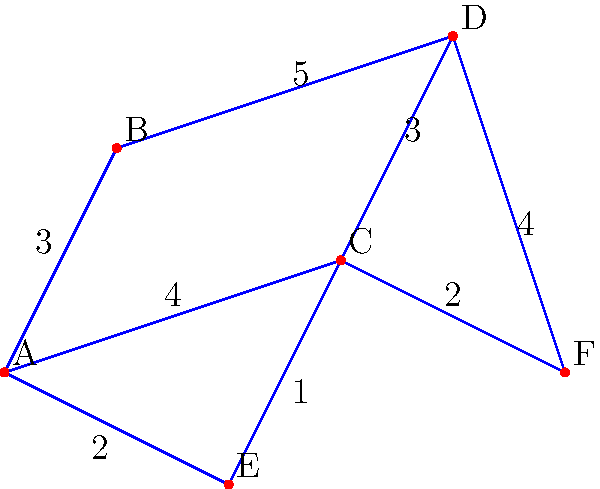As the Student Union leader, you're tasked with designing an efficient network for distributing student information across campus. The graph represents different locations on campus, with edges representing possible connections and their associated costs. What is the total cost of the minimal spanning tree that ensures all locations are connected while minimizing the overall expense? To find the minimal spanning tree, we'll use Kruskal's algorithm:

1. Sort all edges by weight in ascending order:
   (C,E): 1
   (A,E): 2
   (C,F): 2
   (A,B): 3
   (C,D): 3
   (A,C): 4
   (D,F): 4
   (B,D): 5

2. Start with an empty set and add edges that don't create cycles:
   - Add (C,E): 1
   - Add (A,E): 2
   - Add (C,F): 2
   - Add (A,B): 3
   - Add (C,D): 3

3. We now have a minimal spanning tree connecting all vertices.

4. Calculate the total cost:
   $1 + 2 + 2 + 3 + 3 = 11$

Therefore, the total cost of the minimal spanning tree is 11.
Answer: 11 